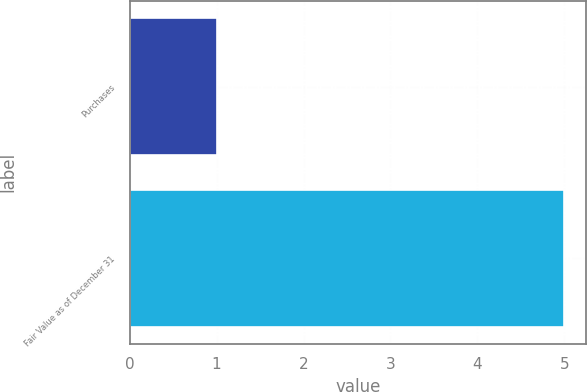<chart> <loc_0><loc_0><loc_500><loc_500><bar_chart><fcel>Purchases<fcel>Fair Value as of December 31<nl><fcel>1<fcel>5<nl></chart> 